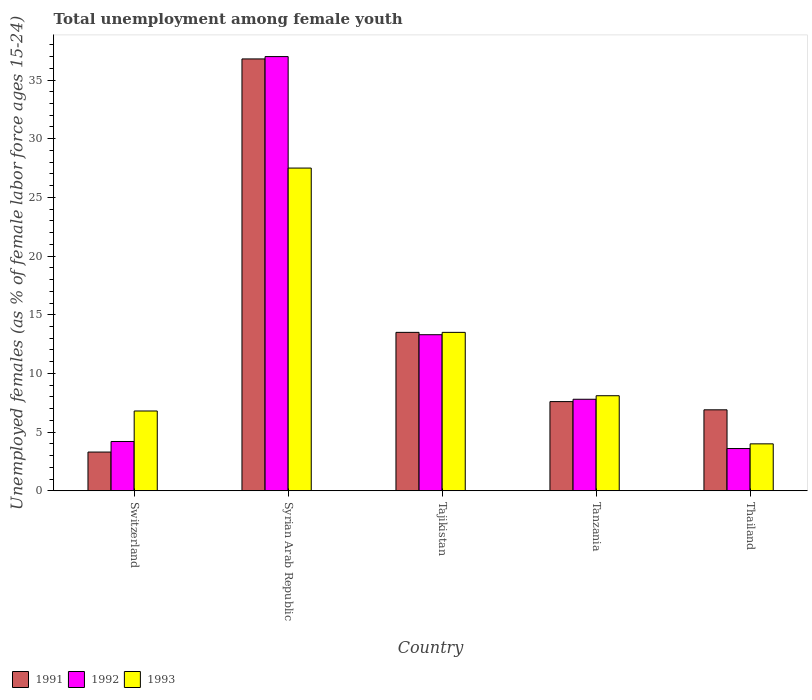What is the label of the 5th group of bars from the left?
Provide a short and direct response. Thailand. In how many cases, is the number of bars for a given country not equal to the number of legend labels?
Your response must be concise. 0. What is the percentage of unemployed females in in 1991 in Tajikistan?
Your response must be concise. 13.5. Across all countries, what is the minimum percentage of unemployed females in in 1991?
Offer a terse response. 3.3. In which country was the percentage of unemployed females in in 1992 maximum?
Your answer should be very brief. Syrian Arab Republic. In which country was the percentage of unemployed females in in 1992 minimum?
Offer a terse response. Thailand. What is the total percentage of unemployed females in in 1992 in the graph?
Provide a short and direct response. 65.9. What is the difference between the percentage of unemployed females in in 1991 in Tajikistan and that in Tanzania?
Make the answer very short. 5.9. What is the difference between the percentage of unemployed females in in 1993 in Switzerland and the percentage of unemployed females in in 1991 in Tanzania?
Make the answer very short. -0.8. What is the average percentage of unemployed females in in 1991 per country?
Your response must be concise. 13.62. What is the difference between the percentage of unemployed females in of/in 1992 and percentage of unemployed females in of/in 1993 in Tanzania?
Offer a terse response. -0.3. In how many countries, is the percentage of unemployed females in in 1993 greater than 2 %?
Make the answer very short. 5. What is the ratio of the percentage of unemployed females in in 1992 in Tanzania to that in Thailand?
Make the answer very short. 2.17. Is the difference between the percentage of unemployed females in in 1992 in Switzerland and Thailand greater than the difference between the percentage of unemployed females in in 1993 in Switzerland and Thailand?
Ensure brevity in your answer.  No. What is the difference between the highest and the second highest percentage of unemployed females in in 1992?
Your answer should be compact. -23.7. What is the difference between the highest and the lowest percentage of unemployed females in in 1992?
Give a very brief answer. 33.4. How many countries are there in the graph?
Your answer should be compact. 5. What is the difference between two consecutive major ticks on the Y-axis?
Your response must be concise. 5. Are the values on the major ticks of Y-axis written in scientific E-notation?
Ensure brevity in your answer.  No. Does the graph contain any zero values?
Ensure brevity in your answer.  No. Does the graph contain grids?
Your answer should be compact. No. What is the title of the graph?
Your answer should be compact. Total unemployment among female youth. Does "2007" appear as one of the legend labels in the graph?
Provide a short and direct response. No. What is the label or title of the Y-axis?
Offer a very short reply. Unemployed females (as % of female labor force ages 15-24). What is the Unemployed females (as % of female labor force ages 15-24) in 1991 in Switzerland?
Your answer should be compact. 3.3. What is the Unemployed females (as % of female labor force ages 15-24) in 1992 in Switzerland?
Provide a succinct answer. 4.2. What is the Unemployed females (as % of female labor force ages 15-24) in 1993 in Switzerland?
Keep it short and to the point. 6.8. What is the Unemployed females (as % of female labor force ages 15-24) of 1991 in Syrian Arab Republic?
Give a very brief answer. 36.8. What is the Unemployed females (as % of female labor force ages 15-24) in 1992 in Syrian Arab Republic?
Your answer should be compact. 37. What is the Unemployed females (as % of female labor force ages 15-24) in 1992 in Tajikistan?
Give a very brief answer. 13.3. What is the Unemployed females (as % of female labor force ages 15-24) in 1991 in Tanzania?
Ensure brevity in your answer.  7.6. What is the Unemployed females (as % of female labor force ages 15-24) of 1992 in Tanzania?
Your answer should be compact. 7.8. What is the Unemployed females (as % of female labor force ages 15-24) in 1993 in Tanzania?
Your answer should be very brief. 8.1. What is the Unemployed females (as % of female labor force ages 15-24) of 1991 in Thailand?
Offer a terse response. 6.9. What is the Unemployed females (as % of female labor force ages 15-24) in 1992 in Thailand?
Ensure brevity in your answer.  3.6. What is the Unemployed females (as % of female labor force ages 15-24) of 1993 in Thailand?
Your answer should be very brief. 4. Across all countries, what is the maximum Unemployed females (as % of female labor force ages 15-24) in 1991?
Provide a short and direct response. 36.8. Across all countries, what is the maximum Unemployed females (as % of female labor force ages 15-24) in 1993?
Make the answer very short. 27.5. Across all countries, what is the minimum Unemployed females (as % of female labor force ages 15-24) in 1991?
Give a very brief answer. 3.3. Across all countries, what is the minimum Unemployed females (as % of female labor force ages 15-24) in 1992?
Your response must be concise. 3.6. Across all countries, what is the minimum Unemployed females (as % of female labor force ages 15-24) of 1993?
Make the answer very short. 4. What is the total Unemployed females (as % of female labor force ages 15-24) in 1991 in the graph?
Your answer should be compact. 68.1. What is the total Unemployed females (as % of female labor force ages 15-24) of 1992 in the graph?
Provide a short and direct response. 65.9. What is the total Unemployed females (as % of female labor force ages 15-24) in 1993 in the graph?
Offer a very short reply. 59.9. What is the difference between the Unemployed females (as % of female labor force ages 15-24) in 1991 in Switzerland and that in Syrian Arab Republic?
Ensure brevity in your answer.  -33.5. What is the difference between the Unemployed females (as % of female labor force ages 15-24) in 1992 in Switzerland and that in Syrian Arab Republic?
Keep it short and to the point. -32.8. What is the difference between the Unemployed females (as % of female labor force ages 15-24) of 1993 in Switzerland and that in Syrian Arab Republic?
Offer a terse response. -20.7. What is the difference between the Unemployed females (as % of female labor force ages 15-24) of 1992 in Switzerland and that in Tajikistan?
Give a very brief answer. -9.1. What is the difference between the Unemployed females (as % of female labor force ages 15-24) of 1992 in Switzerland and that in Tanzania?
Provide a succinct answer. -3.6. What is the difference between the Unemployed females (as % of female labor force ages 15-24) of 1991 in Switzerland and that in Thailand?
Provide a short and direct response. -3.6. What is the difference between the Unemployed females (as % of female labor force ages 15-24) in 1993 in Switzerland and that in Thailand?
Your answer should be very brief. 2.8. What is the difference between the Unemployed females (as % of female labor force ages 15-24) of 1991 in Syrian Arab Republic and that in Tajikistan?
Ensure brevity in your answer.  23.3. What is the difference between the Unemployed females (as % of female labor force ages 15-24) of 1992 in Syrian Arab Republic and that in Tajikistan?
Offer a very short reply. 23.7. What is the difference between the Unemployed females (as % of female labor force ages 15-24) in 1993 in Syrian Arab Republic and that in Tajikistan?
Offer a very short reply. 14. What is the difference between the Unemployed females (as % of female labor force ages 15-24) of 1991 in Syrian Arab Republic and that in Tanzania?
Provide a short and direct response. 29.2. What is the difference between the Unemployed females (as % of female labor force ages 15-24) in 1992 in Syrian Arab Republic and that in Tanzania?
Your answer should be very brief. 29.2. What is the difference between the Unemployed females (as % of female labor force ages 15-24) in 1991 in Syrian Arab Republic and that in Thailand?
Keep it short and to the point. 29.9. What is the difference between the Unemployed females (as % of female labor force ages 15-24) in 1992 in Syrian Arab Republic and that in Thailand?
Ensure brevity in your answer.  33.4. What is the difference between the Unemployed females (as % of female labor force ages 15-24) of 1991 in Tajikistan and that in Tanzania?
Your response must be concise. 5.9. What is the difference between the Unemployed females (as % of female labor force ages 15-24) in 1992 in Tajikistan and that in Tanzania?
Give a very brief answer. 5.5. What is the difference between the Unemployed females (as % of female labor force ages 15-24) of 1993 in Tajikistan and that in Tanzania?
Provide a succinct answer. 5.4. What is the difference between the Unemployed females (as % of female labor force ages 15-24) in 1991 in Tajikistan and that in Thailand?
Your answer should be very brief. 6.6. What is the difference between the Unemployed females (as % of female labor force ages 15-24) in 1993 in Tajikistan and that in Thailand?
Make the answer very short. 9.5. What is the difference between the Unemployed females (as % of female labor force ages 15-24) in 1992 in Tanzania and that in Thailand?
Give a very brief answer. 4.2. What is the difference between the Unemployed females (as % of female labor force ages 15-24) of 1991 in Switzerland and the Unemployed females (as % of female labor force ages 15-24) of 1992 in Syrian Arab Republic?
Keep it short and to the point. -33.7. What is the difference between the Unemployed females (as % of female labor force ages 15-24) of 1991 in Switzerland and the Unemployed females (as % of female labor force ages 15-24) of 1993 in Syrian Arab Republic?
Your answer should be very brief. -24.2. What is the difference between the Unemployed females (as % of female labor force ages 15-24) of 1992 in Switzerland and the Unemployed females (as % of female labor force ages 15-24) of 1993 in Syrian Arab Republic?
Your response must be concise. -23.3. What is the difference between the Unemployed females (as % of female labor force ages 15-24) of 1991 in Switzerland and the Unemployed females (as % of female labor force ages 15-24) of 1992 in Tajikistan?
Make the answer very short. -10. What is the difference between the Unemployed females (as % of female labor force ages 15-24) in 1992 in Switzerland and the Unemployed females (as % of female labor force ages 15-24) in 1993 in Tajikistan?
Offer a very short reply. -9.3. What is the difference between the Unemployed females (as % of female labor force ages 15-24) in 1991 in Switzerland and the Unemployed females (as % of female labor force ages 15-24) in 1992 in Tanzania?
Your answer should be compact. -4.5. What is the difference between the Unemployed females (as % of female labor force ages 15-24) in 1991 in Switzerland and the Unemployed females (as % of female labor force ages 15-24) in 1993 in Tanzania?
Keep it short and to the point. -4.8. What is the difference between the Unemployed females (as % of female labor force ages 15-24) in 1992 in Switzerland and the Unemployed females (as % of female labor force ages 15-24) in 1993 in Tanzania?
Provide a succinct answer. -3.9. What is the difference between the Unemployed females (as % of female labor force ages 15-24) of 1991 in Switzerland and the Unemployed females (as % of female labor force ages 15-24) of 1992 in Thailand?
Provide a succinct answer. -0.3. What is the difference between the Unemployed females (as % of female labor force ages 15-24) of 1991 in Syrian Arab Republic and the Unemployed females (as % of female labor force ages 15-24) of 1992 in Tajikistan?
Ensure brevity in your answer.  23.5. What is the difference between the Unemployed females (as % of female labor force ages 15-24) of 1991 in Syrian Arab Republic and the Unemployed females (as % of female labor force ages 15-24) of 1993 in Tajikistan?
Ensure brevity in your answer.  23.3. What is the difference between the Unemployed females (as % of female labor force ages 15-24) in 1992 in Syrian Arab Republic and the Unemployed females (as % of female labor force ages 15-24) in 1993 in Tajikistan?
Give a very brief answer. 23.5. What is the difference between the Unemployed females (as % of female labor force ages 15-24) of 1991 in Syrian Arab Republic and the Unemployed females (as % of female labor force ages 15-24) of 1992 in Tanzania?
Offer a very short reply. 29. What is the difference between the Unemployed females (as % of female labor force ages 15-24) in 1991 in Syrian Arab Republic and the Unemployed females (as % of female labor force ages 15-24) in 1993 in Tanzania?
Your response must be concise. 28.7. What is the difference between the Unemployed females (as % of female labor force ages 15-24) in 1992 in Syrian Arab Republic and the Unemployed females (as % of female labor force ages 15-24) in 1993 in Tanzania?
Give a very brief answer. 28.9. What is the difference between the Unemployed females (as % of female labor force ages 15-24) of 1991 in Syrian Arab Republic and the Unemployed females (as % of female labor force ages 15-24) of 1992 in Thailand?
Your answer should be very brief. 33.2. What is the difference between the Unemployed females (as % of female labor force ages 15-24) of 1991 in Syrian Arab Republic and the Unemployed females (as % of female labor force ages 15-24) of 1993 in Thailand?
Offer a terse response. 32.8. What is the difference between the Unemployed females (as % of female labor force ages 15-24) in 1992 in Tanzania and the Unemployed females (as % of female labor force ages 15-24) in 1993 in Thailand?
Your answer should be compact. 3.8. What is the average Unemployed females (as % of female labor force ages 15-24) in 1991 per country?
Provide a succinct answer. 13.62. What is the average Unemployed females (as % of female labor force ages 15-24) in 1992 per country?
Your answer should be very brief. 13.18. What is the average Unemployed females (as % of female labor force ages 15-24) in 1993 per country?
Your answer should be very brief. 11.98. What is the difference between the Unemployed females (as % of female labor force ages 15-24) in 1991 and Unemployed females (as % of female labor force ages 15-24) in 1992 in Switzerland?
Make the answer very short. -0.9. What is the difference between the Unemployed females (as % of female labor force ages 15-24) of 1991 and Unemployed females (as % of female labor force ages 15-24) of 1993 in Switzerland?
Provide a succinct answer. -3.5. What is the difference between the Unemployed females (as % of female labor force ages 15-24) of 1992 and Unemployed females (as % of female labor force ages 15-24) of 1993 in Switzerland?
Your answer should be very brief. -2.6. What is the difference between the Unemployed females (as % of female labor force ages 15-24) in 1992 and Unemployed females (as % of female labor force ages 15-24) in 1993 in Syrian Arab Republic?
Ensure brevity in your answer.  9.5. What is the difference between the Unemployed females (as % of female labor force ages 15-24) of 1991 and Unemployed females (as % of female labor force ages 15-24) of 1992 in Tajikistan?
Provide a succinct answer. 0.2. What is the difference between the Unemployed females (as % of female labor force ages 15-24) in 1992 and Unemployed females (as % of female labor force ages 15-24) in 1993 in Tajikistan?
Offer a very short reply. -0.2. What is the difference between the Unemployed females (as % of female labor force ages 15-24) in 1991 and Unemployed females (as % of female labor force ages 15-24) in 1992 in Tanzania?
Your answer should be very brief. -0.2. What is the difference between the Unemployed females (as % of female labor force ages 15-24) in 1991 and Unemployed females (as % of female labor force ages 15-24) in 1993 in Tanzania?
Provide a succinct answer. -0.5. What is the difference between the Unemployed females (as % of female labor force ages 15-24) of 1991 and Unemployed females (as % of female labor force ages 15-24) of 1993 in Thailand?
Keep it short and to the point. 2.9. What is the difference between the Unemployed females (as % of female labor force ages 15-24) of 1992 and Unemployed females (as % of female labor force ages 15-24) of 1993 in Thailand?
Your response must be concise. -0.4. What is the ratio of the Unemployed females (as % of female labor force ages 15-24) of 1991 in Switzerland to that in Syrian Arab Republic?
Make the answer very short. 0.09. What is the ratio of the Unemployed females (as % of female labor force ages 15-24) of 1992 in Switzerland to that in Syrian Arab Republic?
Give a very brief answer. 0.11. What is the ratio of the Unemployed females (as % of female labor force ages 15-24) in 1993 in Switzerland to that in Syrian Arab Republic?
Your response must be concise. 0.25. What is the ratio of the Unemployed females (as % of female labor force ages 15-24) of 1991 in Switzerland to that in Tajikistan?
Your answer should be compact. 0.24. What is the ratio of the Unemployed females (as % of female labor force ages 15-24) of 1992 in Switzerland to that in Tajikistan?
Ensure brevity in your answer.  0.32. What is the ratio of the Unemployed females (as % of female labor force ages 15-24) in 1993 in Switzerland to that in Tajikistan?
Your answer should be compact. 0.5. What is the ratio of the Unemployed females (as % of female labor force ages 15-24) of 1991 in Switzerland to that in Tanzania?
Give a very brief answer. 0.43. What is the ratio of the Unemployed females (as % of female labor force ages 15-24) of 1992 in Switzerland to that in Tanzania?
Offer a very short reply. 0.54. What is the ratio of the Unemployed females (as % of female labor force ages 15-24) of 1993 in Switzerland to that in Tanzania?
Offer a very short reply. 0.84. What is the ratio of the Unemployed females (as % of female labor force ages 15-24) in 1991 in Switzerland to that in Thailand?
Give a very brief answer. 0.48. What is the ratio of the Unemployed females (as % of female labor force ages 15-24) in 1993 in Switzerland to that in Thailand?
Your answer should be compact. 1.7. What is the ratio of the Unemployed females (as % of female labor force ages 15-24) in 1991 in Syrian Arab Republic to that in Tajikistan?
Provide a succinct answer. 2.73. What is the ratio of the Unemployed females (as % of female labor force ages 15-24) in 1992 in Syrian Arab Republic to that in Tajikistan?
Provide a short and direct response. 2.78. What is the ratio of the Unemployed females (as % of female labor force ages 15-24) in 1993 in Syrian Arab Republic to that in Tajikistan?
Offer a very short reply. 2.04. What is the ratio of the Unemployed females (as % of female labor force ages 15-24) of 1991 in Syrian Arab Republic to that in Tanzania?
Your answer should be compact. 4.84. What is the ratio of the Unemployed females (as % of female labor force ages 15-24) in 1992 in Syrian Arab Republic to that in Tanzania?
Provide a succinct answer. 4.74. What is the ratio of the Unemployed females (as % of female labor force ages 15-24) in 1993 in Syrian Arab Republic to that in Tanzania?
Give a very brief answer. 3.4. What is the ratio of the Unemployed females (as % of female labor force ages 15-24) of 1991 in Syrian Arab Republic to that in Thailand?
Offer a very short reply. 5.33. What is the ratio of the Unemployed females (as % of female labor force ages 15-24) in 1992 in Syrian Arab Republic to that in Thailand?
Make the answer very short. 10.28. What is the ratio of the Unemployed females (as % of female labor force ages 15-24) of 1993 in Syrian Arab Republic to that in Thailand?
Give a very brief answer. 6.88. What is the ratio of the Unemployed females (as % of female labor force ages 15-24) of 1991 in Tajikistan to that in Tanzania?
Keep it short and to the point. 1.78. What is the ratio of the Unemployed females (as % of female labor force ages 15-24) in 1992 in Tajikistan to that in Tanzania?
Keep it short and to the point. 1.71. What is the ratio of the Unemployed females (as % of female labor force ages 15-24) of 1993 in Tajikistan to that in Tanzania?
Provide a succinct answer. 1.67. What is the ratio of the Unemployed females (as % of female labor force ages 15-24) in 1991 in Tajikistan to that in Thailand?
Your answer should be very brief. 1.96. What is the ratio of the Unemployed females (as % of female labor force ages 15-24) of 1992 in Tajikistan to that in Thailand?
Ensure brevity in your answer.  3.69. What is the ratio of the Unemployed females (as % of female labor force ages 15-24) in 1993 in Tajikistan to that in Thailand?
Ensure brevity in your answer.  3.38. What is the ratio of the Unemployed females (as % of female labor force ages 15-24) in 1991 in Tanzania to that in Thailand?
Your answer should be compact. 1.1. What is the ratio of the Unemployed females (as % of female labor force ages 15-24) of 1992 in Tanzania to that in Thailand?
Provide a succinct answer. 2.17. What is the ratio of the Unemployed females (as % of female labor force ages 15-24) of 1993 in Tanzania to that in Thailand?
Give a very brief answer. 2.02. What is the difference between the highest and the second highest Unemployed females (as % of female labor force ages 15-24) in 1991?
Offer a very short reply. 23.3. What is the difference between the highest and the second highest Unemployed females (as % of female labor force ages 15-24) of 1992?
Provide a succinct answer. 23.7. What is the difference between the highest and the second highest Unemployed females (as % of female labor force ages 15-24) of 1993?
Your response must be concise. 14. What is the difference between the highest and the lowest Unemployed females (as % of female labor force ages 15-24) of 1991?
Give a very brief answer. 33.5. What is the difference between the highest and the lowest Unemployed females (as % of female labor force ages 15-24) in 1992?
Offer a terse response. 33.4. 